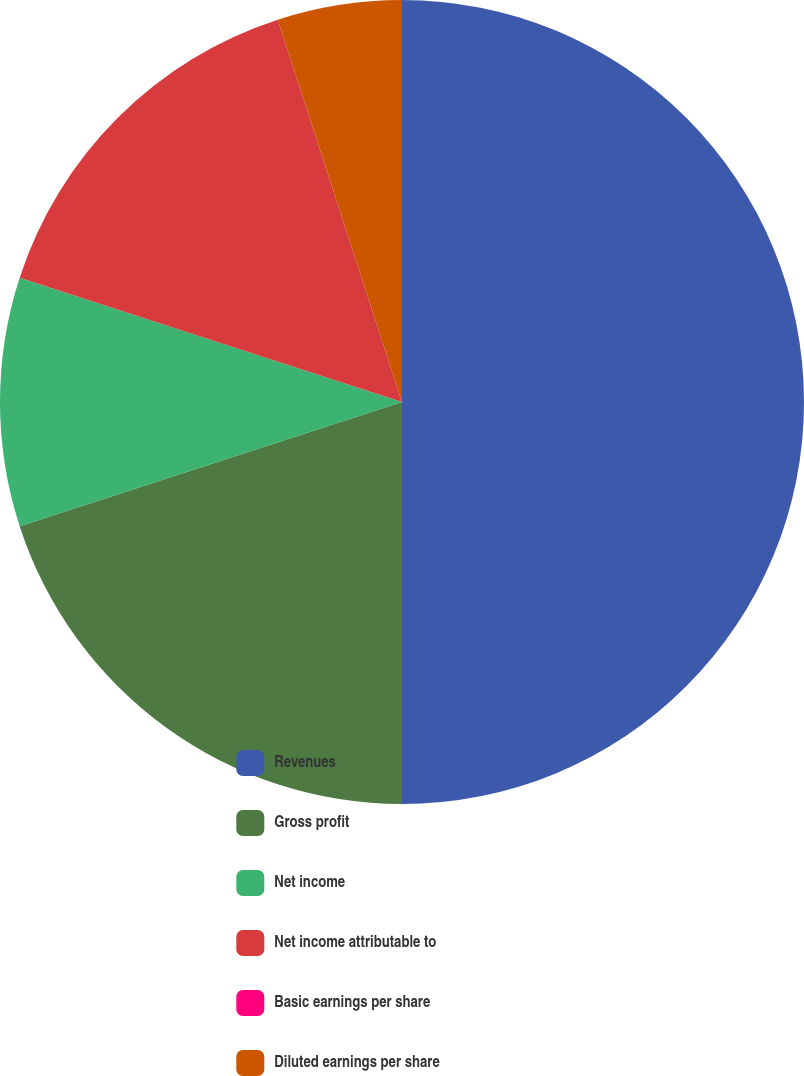Convert chart to OTSL. <chart><loc_0><loc_0><loc_500><loc_500><pie_chart><fcel>Revenues<fcel>Gross profit<fcel>Net income<fcel>Net income attributable to<fcel>Basic earnings per share<fcel>Diluted earnings per share<nl><fcel>50.0%<fcel>20.0%<fcel>10.0%<fcel>15.0%<fcel>0.0%<fcel>5.0%<nl></chart> 